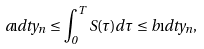Convert formula to latex. <formula><loc_0><loc_0><loc_500><loc_500>a \i d t y _ { n } \leq \int _ { 0 } ^ { T } S ( \tau ) d \tau \leq b \i d t y _ { n } ,</formula> 